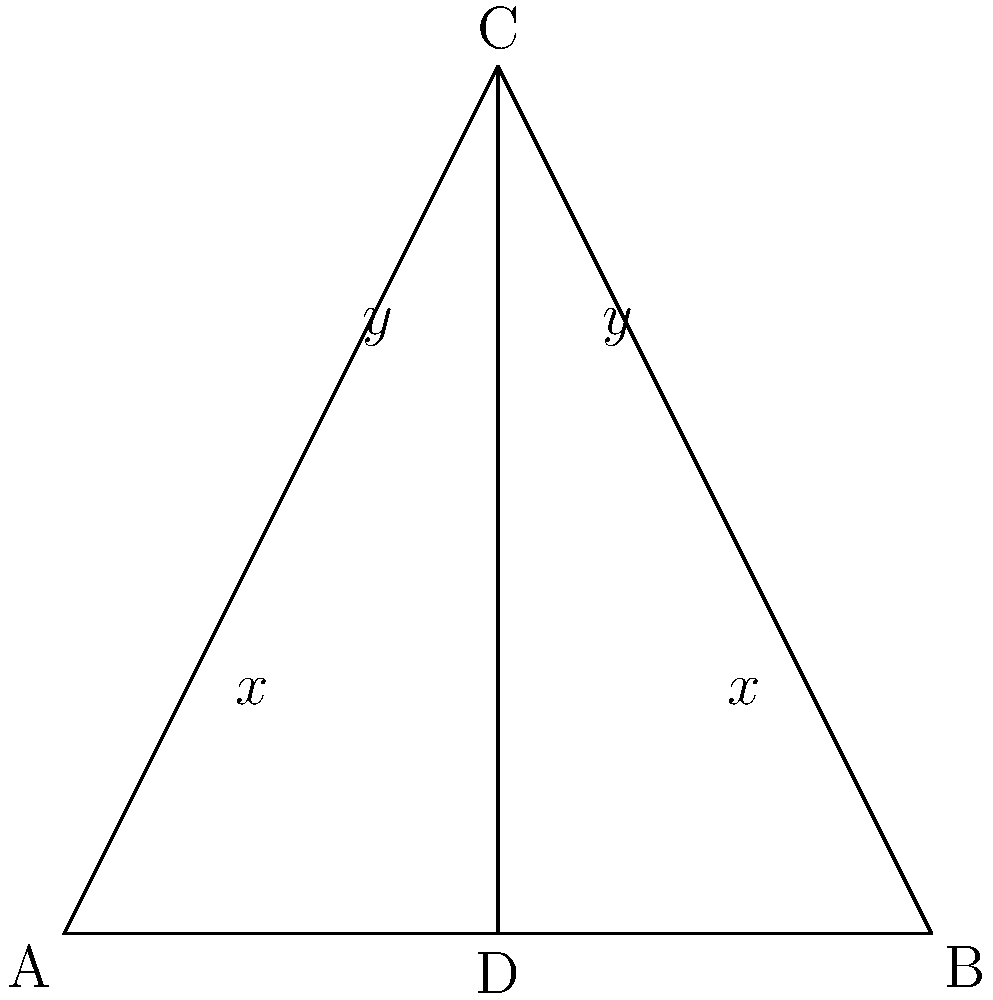In the shadowy heart of Noir City, where alleyways intersect like the tangled web of deceit, two streets meet at point C. The angles formed by these streets are marked as $x$ and $y$. If $\angle ACB = 100°$, what is the value of $x + y$? Let's unravel this mystery step by step:

1) In triangle ACB, we know that $\angle ACB = 100°$.

2) The sum of angles in a triangle is always 180°. So:
   $\angle CAB + \angle ACB + \angle CBA = 180°$

3) We can see that $\angle CAB = x$ and $\angle CBA = x$, as they are vertically opposite angles to the $x$ angles shown.

4) Substituting into the equation from step 2:
   $x + 100° + x = 180°$

5) Simplifying:
   $2x + 100° = 180°$
   $2x = 80°$
   $x = 40°$

6) Now, let's consider the straight line ACD. The angles on a straight line sum to 180°:
   $x + y + y = 180°$

7) We know $x = 40°$, so:
   $40° + 2y = 180°$
   $2y = 140°$
   $y = 70°$

8) The question asks for $x + y$:
   $x + y = 40° + 70° = 110°$

Thus, in this gritty cityscape, the sum of these intersecting angles reveals a truth as clear as the barrel of a .45: 110°.
Answer: $110°$ 